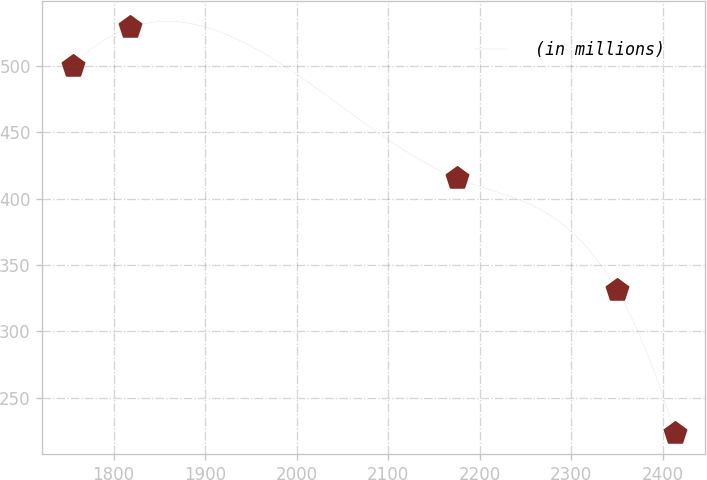<chart> <loc_0><loc_0><loc_500><loc_500><line_chart><ecel><fcel>(in millions)<nl><fcel>1755.11<fcel>500.2<nl><fcel>1818.34<fcel>529.16<nl><fcel>2174.85<fcel>415.54<nl><fcel>2350.09<fcel>330.94<nl><fcel>2413.32<fcel>223.25<nl></chart> 